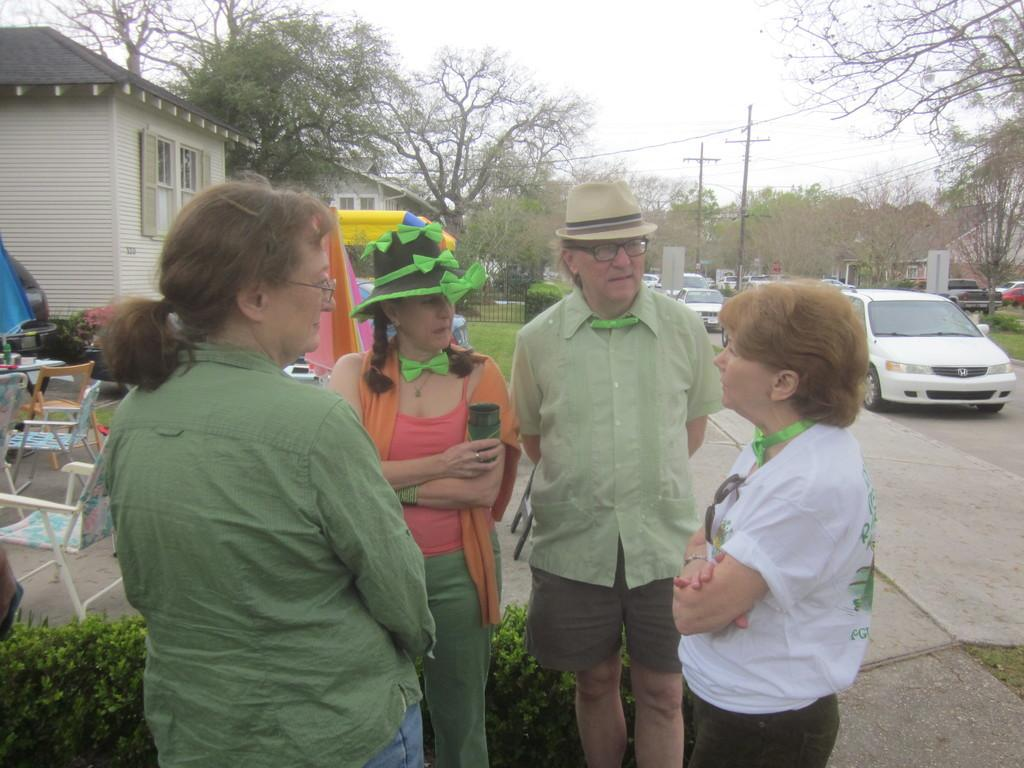How many people are present in the image? There are 4 people standing in the image. What can be seen in the image besides the people? There are chairs, plants, buildings, a fence, vehicles on the road, and trees at the back of the image. What type of objects are the people standing near? The people are standing near chairs. What is the purpose of the fence in the image? The fence serves as a boundary or barrier in the image. What type of dress is being offered to the people in the image? There is no dress being offered in the image; the provided facts do not mention any clothing or items being offered. 